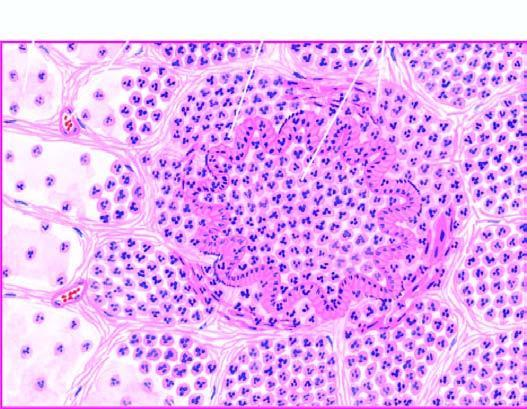re the alveolar septa thickened due to congested capillaries and neutrophilic infiltrate?
Answer the question using a single word or phrase. Yes 